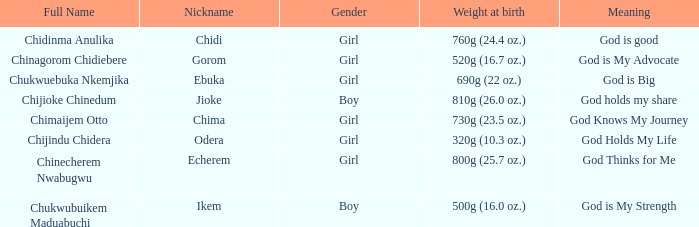What is the nickname of the boy who weighed 810g (26.0 oz.) at birth? Jioke. 